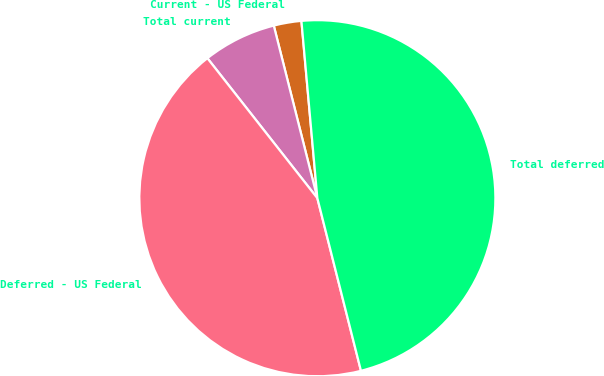Convert chart to OTSL. <chart><loc_0><loc_0><loc_500><loc_500><pie_chart><fcel>Current - US Federal<fcel>Total current<fcel>Deferred - US Federal<fcel>Total deferred<nl><fcel>2.51%<fcel>6.66%<fcel>43.34%<fcel>47.49%<nl></chart> 